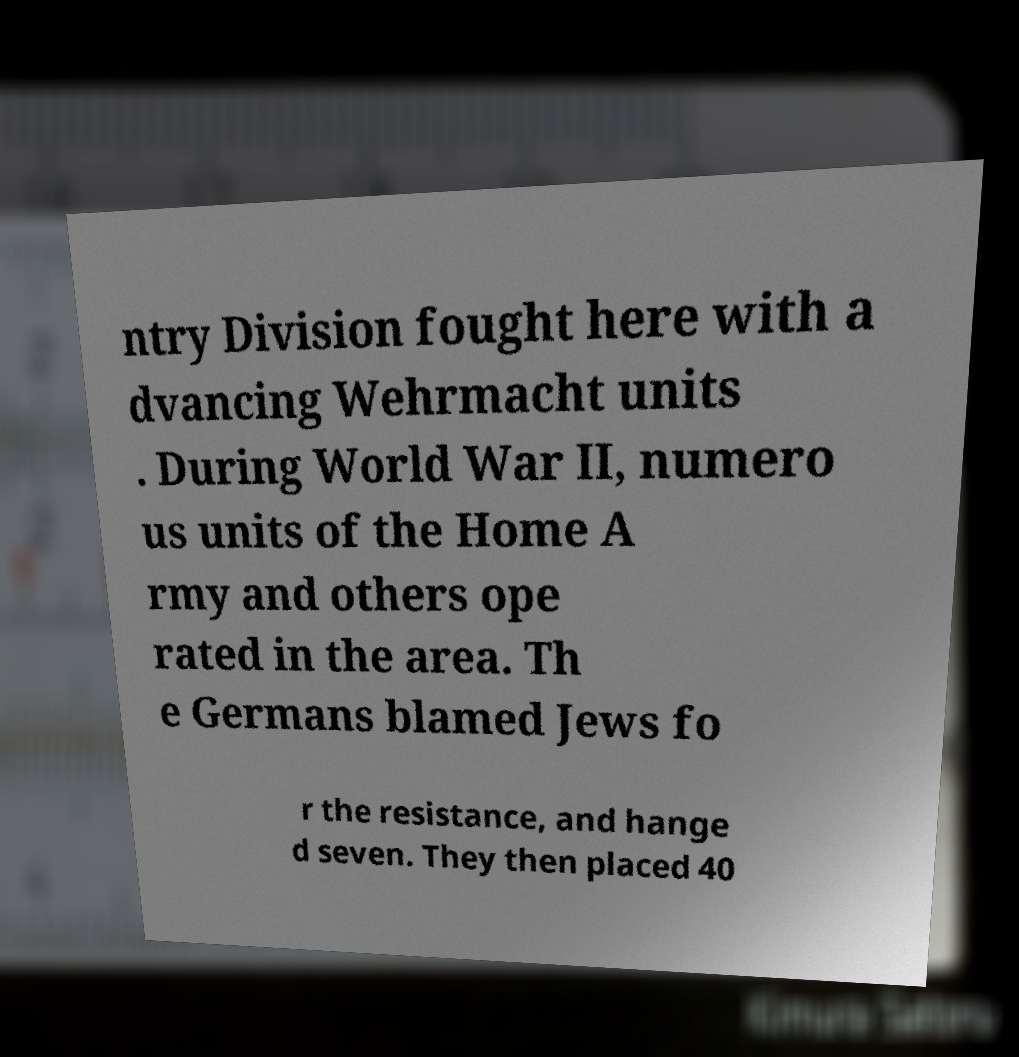Could you assist in decoding the text presented in this image and type it out clearly? ntry Division fought here with a dvancing Wehrmacht units . During World War II, numero us units of the Home A rmy and others ope rated in the area. Th e Germans blamed Jews fo r the resistance, and hange d seven. They then placed 40 